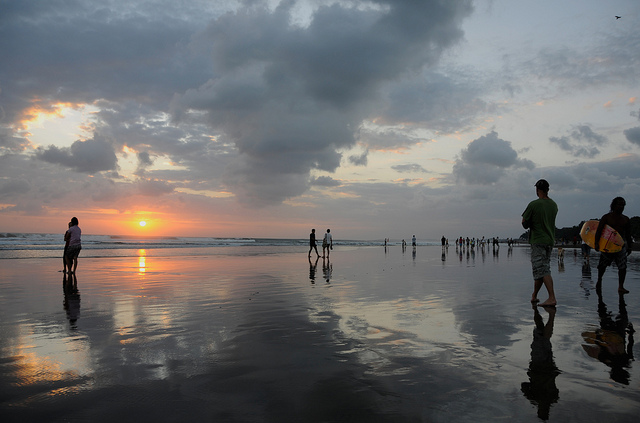<image>What holiday is near? I don't know what holiday is near. The answers are various, it can be 'Christmas', '4th of July', "Valentine's Day" or 'Easter'. What type of vessels are in the water? I am not sure what type of vessels are in the water. It could potentially be surfboards, boats or there could be none at all. What can the people put their garbage in? There is no specific place for people to put their garbage in the image. However, a possible option could be in a trash can or bags. What holiday is near? I am not sure what holiday is near. It could be Christmas or Valentine's Day. What can the people put their garbage in? The people can put their garbage in the trash can. What type of vessels are in the water? It is ambiguous what type of vessels are in the water. It can be seen surfboards, humans, people or boats. 